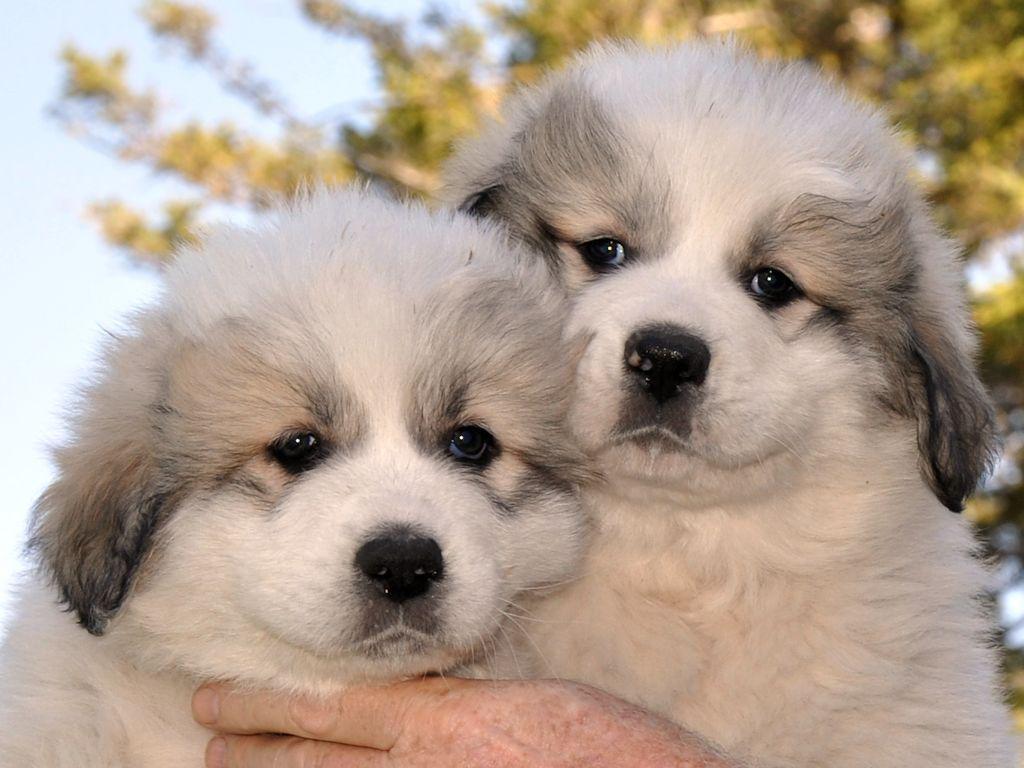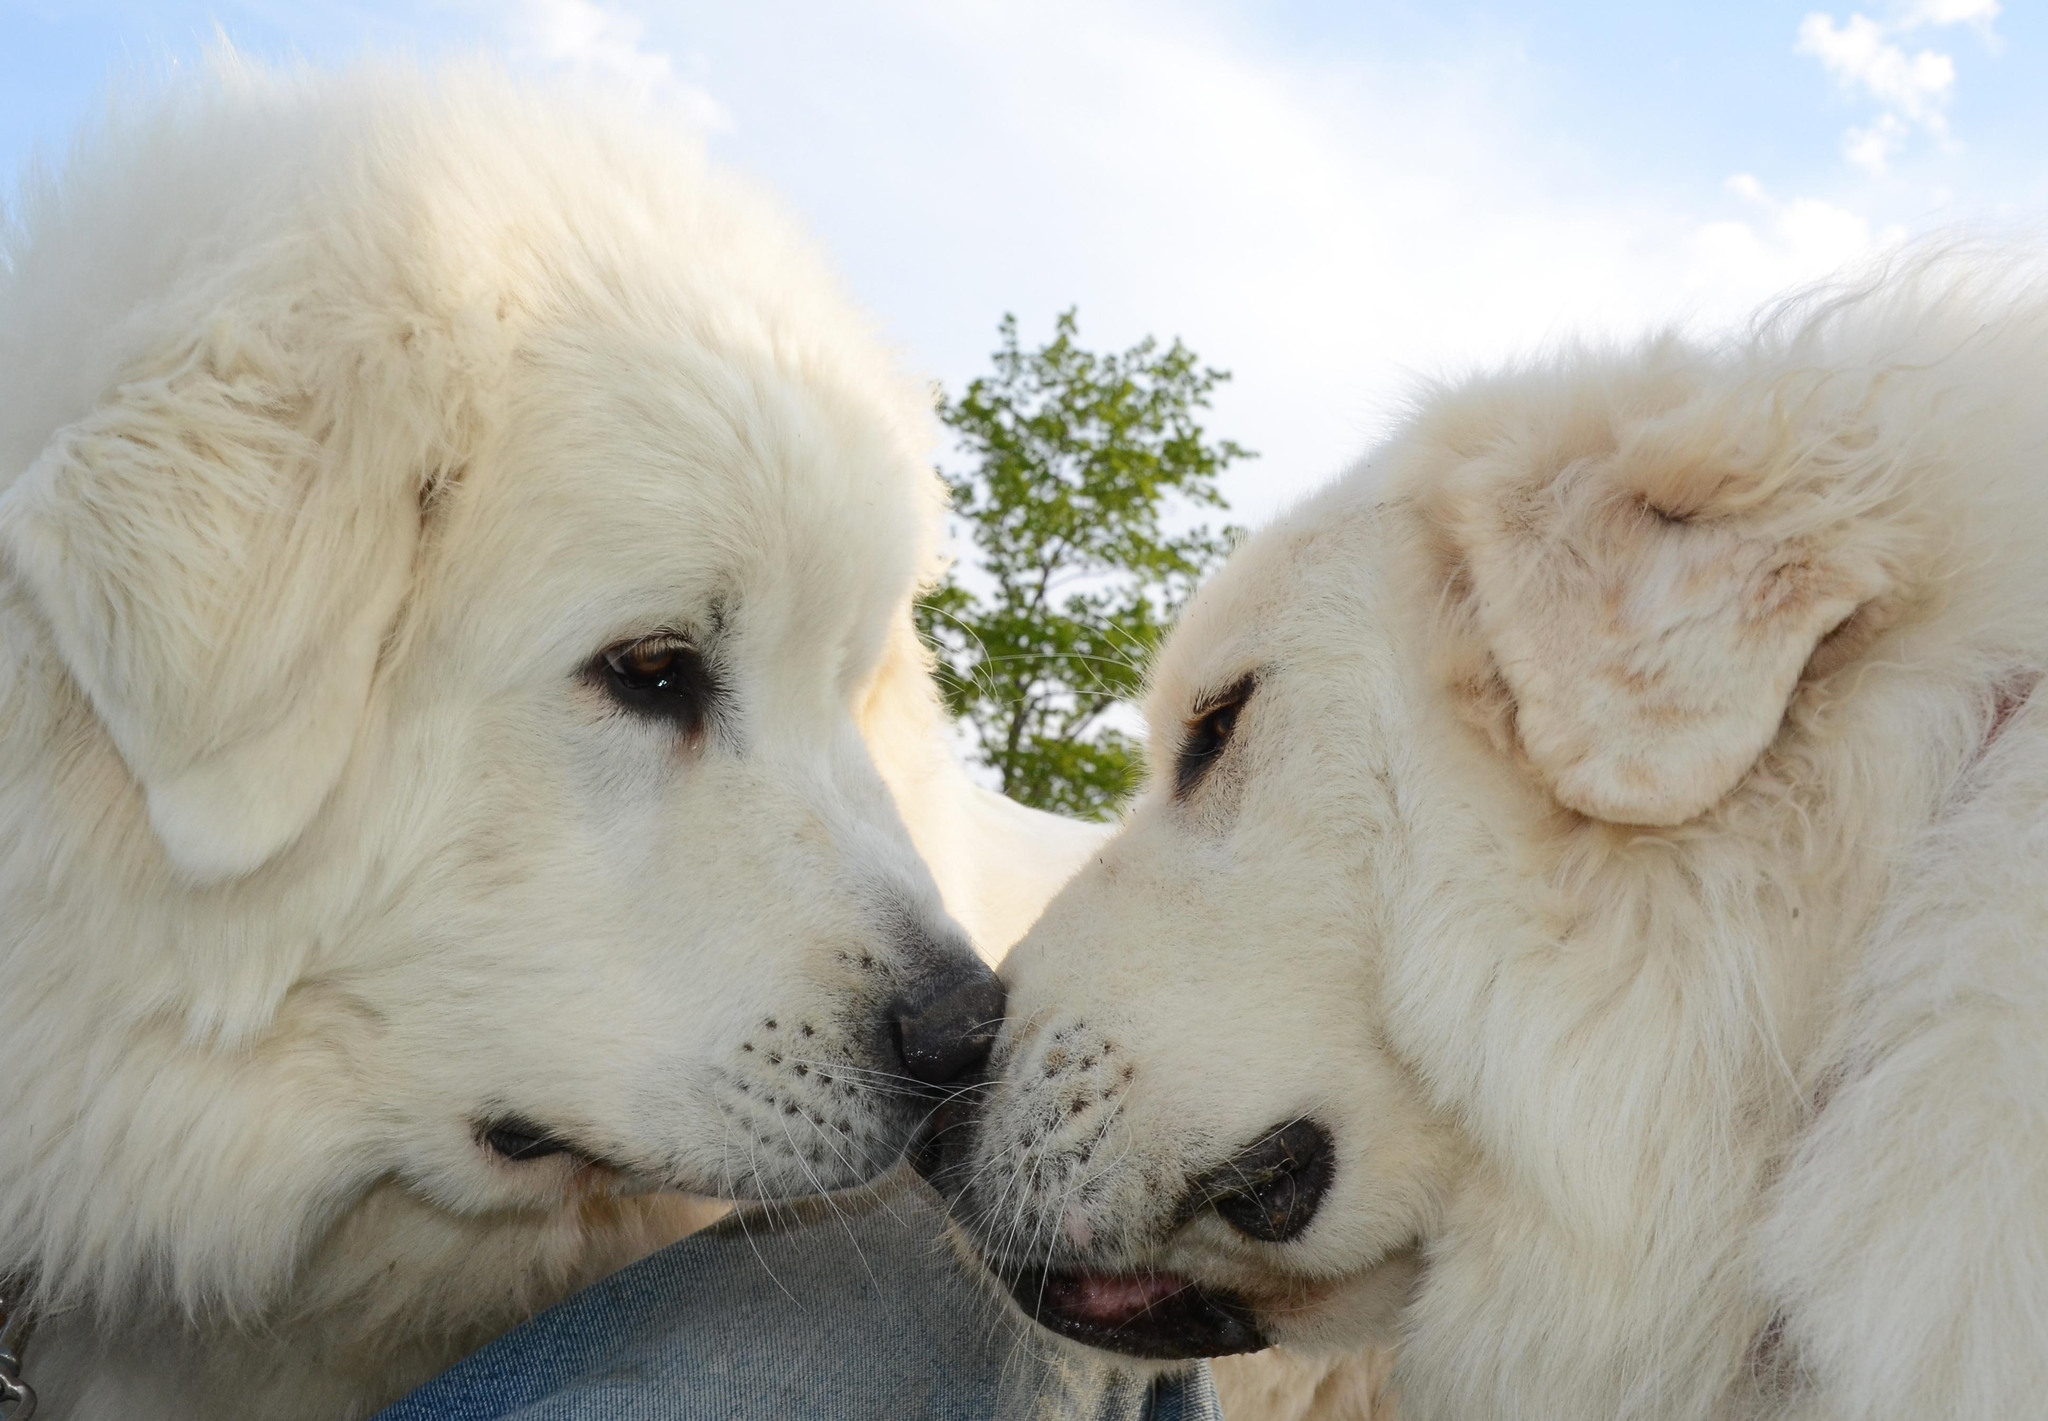The first image is the image on the left, the second image is the image on the right. For the images displayed, is the sentence "There are two dogs together in front of a visible sky in each image." factually correct? Answer yes or no. Yes. The first image is the image on the left, the second image is the image on the right. Evaluate the accuracy of this statement regarding the images: "The sky is visible in both of the images.". Is it true? Answer yes or no. Yes. 